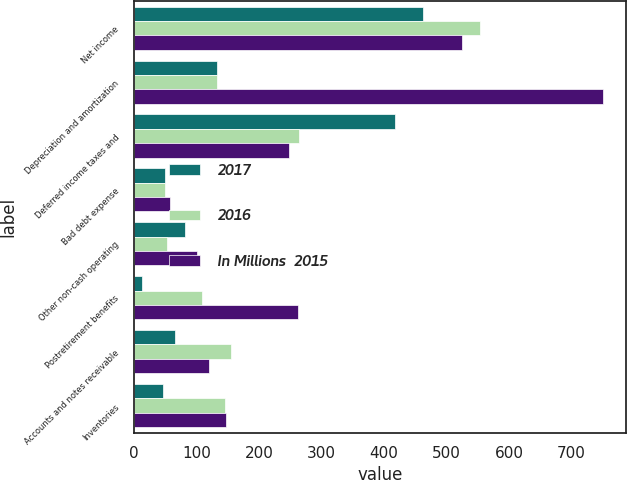Convert chart. <chart><loc_0><loc_0><loc_500><loc_500><stacked_bar_chart><ecel><fcel>Net income<fcel>Depreciation and amortization<fcel>Deferred income taxes and<fcel>Bad debt expense<fcel>Other non-cash operating<fcel>Postretirement benefits<fcel>Accounts and notes receivable<fcel>Inventories<nl><fcel>2017<fcel>462<fcel>133<fcel>417<fcel>49<fcel>82<fcel>12<fcel>66<fcel>46<nl><fcel>2016<fcel>553<fcel>133<fcel>264<fcel>50<fcel>52<fcel>108<fcel>155<fcel>146<nl><fcel>In Millions  2015<fcel>525<fcel>750<fcel>247<fcel>58<fcel>100<fcel>262<fcel>120<fcel>147<nl></chart> 